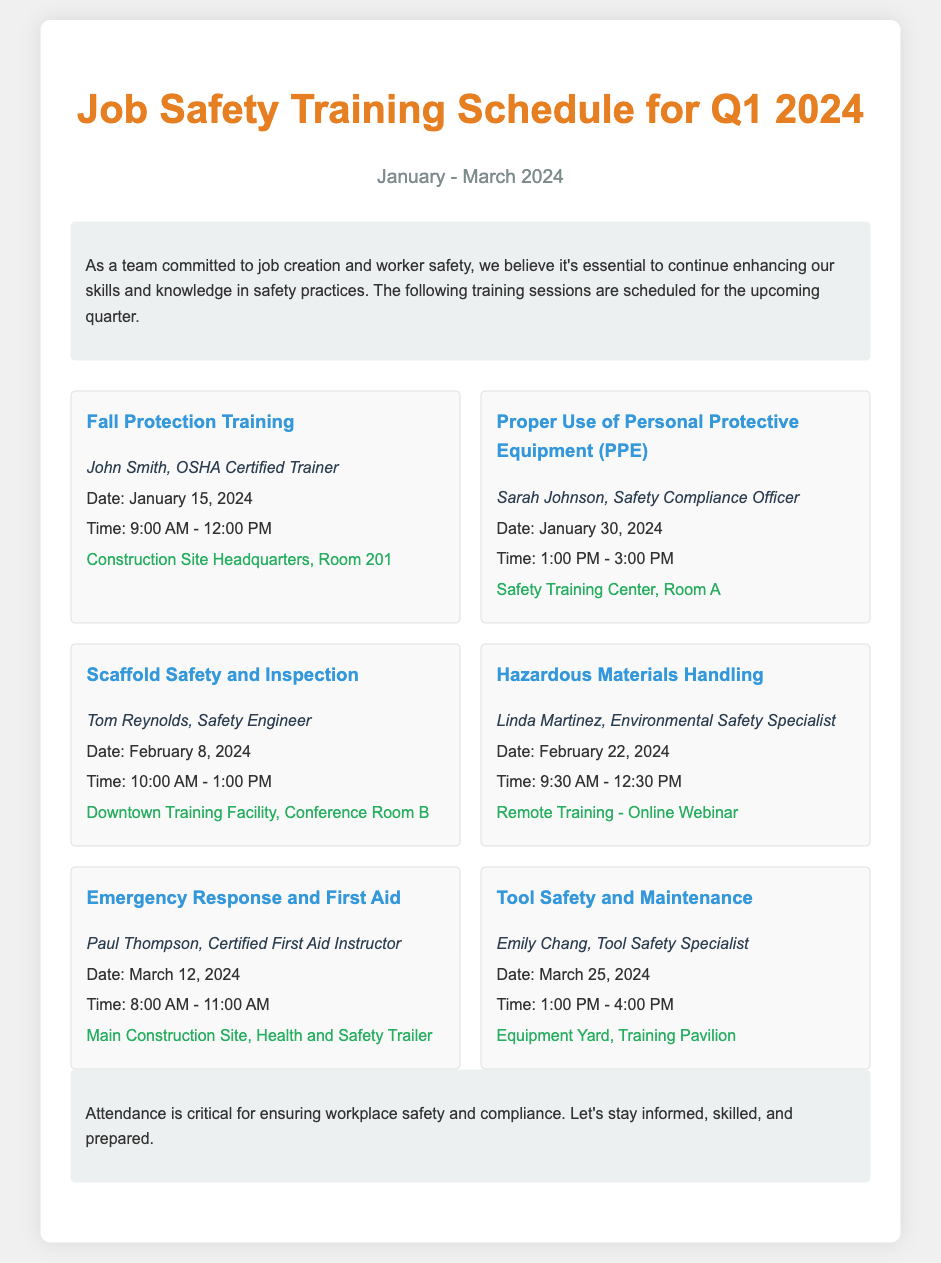What is the title of the document? The title of the document is displayed prominently at the top of the agenda, which is "Job Safety Training Schedule for Q1 2024."
Answer: Job Safety Training Schedule for Q1 2024 What is the date of the Fall Protection Training? The date is provided in the session details, specifically for Fall Protection Training, which is on January 15, 2024.
Answer: January 15, 2024 Who is the trainer for Emergency Response and First Aid? The trainer's name for this session is mentioned in the session details, which is Paul Thompson.
Answer: Paul Thompson How long is the Proper Use of Personal Protective Equipment training? The duration of the training is given by the start and end times provided in the session details, calculated as 2 hours.
Answer: 2 hours Where will the Hazardous Materials Handling training take place? The location is specified in the session details as "Remote Training - Online Webinar."
Answer: Remote Training - Online Webinar What is the scheduled time for Scaffold Safety and Inspection training? The time is specified in the session details, which is from 10:00 AM to 1:00 PM.
Answer: 10:00 AM - 1:00 PM How many training sessions are scheduled in total? Counting the sessions listed in the document, there are six training sessions scheduled in total.
Answer: Six What is the purpose of the introductory paragraph? The introduction explains the commitment to job creation and worker safety, emphasizing the importance of training.
Answer: Enhancing skills and knowledge in safety practices What is the location for the Tool Safety and Maintenance training? The specific location for this training is mentioned in the session details, which is "Equipment Yard, Training Pavilion."
Answer: Equipment Yard, Training Pavilion 